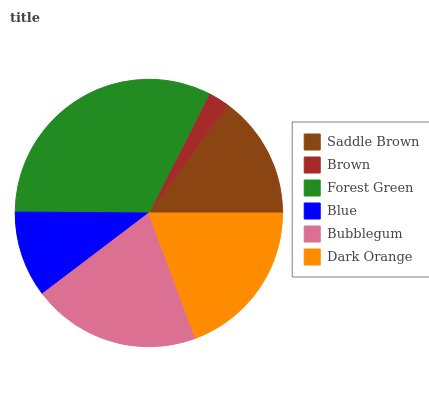Is Brown the minimum?
Answer yes or no. Yes. Is Forest Green the maximum?
Answer yes or no. Yes. Is Forest Green the minimum?
Answer yes or no. No. Is Brown the maximum?
Answer yes or no. No. Is Forest Green greater than Brown?
Answer yes or no. Yes. Is Brown less than Forest Green?
Answer yes or no. Yes. Is Brown greater than Forest Green?
Answer yes or no. No. Is Forest Green less than Brown?
Answer yes or no. No. Is Dark Orange the high median?
Answer yes or no. Yes. Is Saddle Brown the low median?
Answer yes or no. Yes. Is Brown the high median?
Answer yes or no. No. Is Dark Orange the low median?
Answer yes or no. No. 